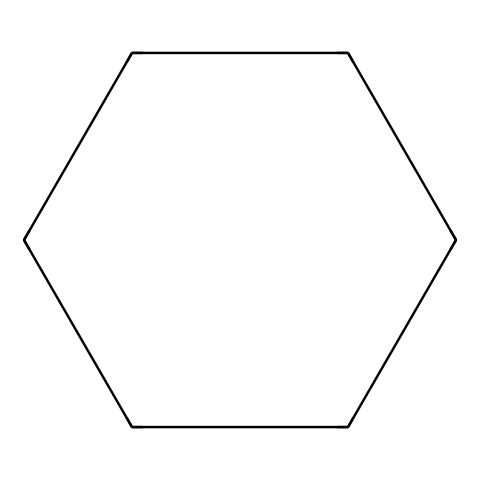How many carbon atoms are in cyclohexane? The SMILES representation "C1CCCCC1" indicates a cyclic structure, wherein the "C" letters denote carbon atoms. Counting these gives us six carbon atoms.
Answer: six What is the molecular formula of cyclohexane? Cyclohexane consists of six carbon atoms and twelve hydrogen atoms, which gives it the molecular formula C6H12.
Answer: C6H12 Is cyclohexane a saturated or unsaturated compound? The presence of only single bonds between carbon atoms and the maximum number of hydrogen atoms indicates that cyclohexane is a saturated compound.
Answer: saturated What is the general formula for cycloalkanes? Cycloalkanes typically follow the general formula CnH2n, where n is the number of carbon atoms. For cyclohexane (n=6), the formula is C6H12.
Answer: CnH2n How does the structure of cyclohexane affect its physical properties? The cyclic structure allows cyclohexane to adopt different conformations (like chair or boat), influencing its stability and reactivity compared to linear alkanes.
Answer: conformations What type of functional groups are absent in cyclohexane? Cyclohexane does not contain any functional groups such as hydroxyl (-OH) or carboxyl (-COOH), as it is composed solely of carbon and hydrogen atoms.
Answer: functional groups In terms of bonds, how many carbon-carbon single bonds are there in cyclohexane? The closed-loop structure indicates that each carbon atom is connected to two neighboring carbon atoms, leading to a total of six carbon-carbon single bonds.
Answer: six 